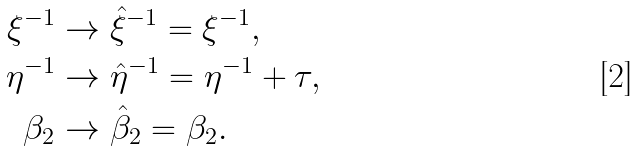<formula> <loc_0><loc_0><loc_500><loc_500>\xi ^ { - 1 } & \to \hat { \xi } ^ { - 1 } = \xi ^ { - 1 } , \\ \eta ^ { - 1 } & \to \hat { \eta } ^ { - 1 } = \eta ^ { - 1 } + \tau , \\ \beta _ { 2 } & \to \hat { \beta } _ { 2 } = \beta _ { 2 } .</formula> 